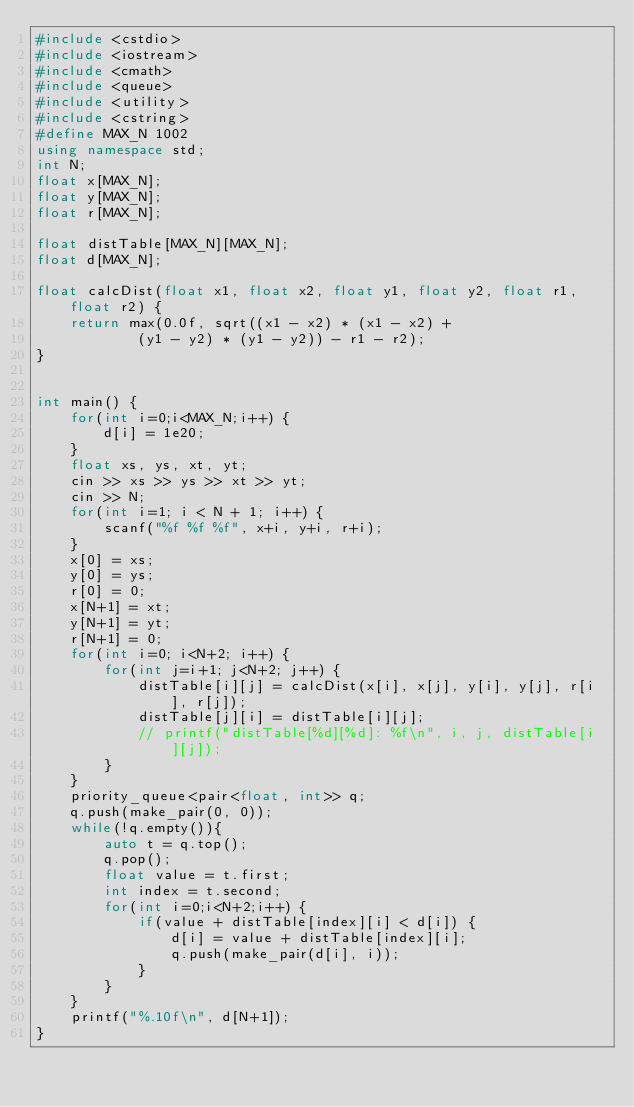<code> <loc_0><loc_0><loc_500><loc_500><_C++_>#include <cstdio>
#include <iostream>
#include <cmath>
#include <queue>
#include <utility>
#include <cstring>
#define MAX_N 1002
using namespace std;
int N;
float x[MAX_N];
float y[MAX_N];
float r[MAX_N];

float distTable[MAX_N][MAX_N];
float d[MAX_N];

float calcDist(float x1, float x2, float y1, float y2, float r1, float r2) {
    return max(0.0f, sqrt((x1 - x2) * (x1 - x2) +
            (y1 - y2) * (y1 - y2)) - r1 - r2);
}


int main() {
    for(int i=0;i<MAX_N;i++) {
        d[i] = 1e20;
    }
    float xs, ys, xt, yt;
    cin >> xs >> ys >> xt >> yt;
    cin >> N;
    for(int i=1; i < N + 1; i++) {
        scanf("%f %f %f", x+i, y+i, r+i);
    }
    x[0] = xs;
    y[0] = ys;
    r[0] = 0;
    x[N+1] = xt;
    y[N+1] = yt;
    r[N+1] = 0;
    for(int i=0; i<N+2; i++) {
        for(int j=i+1; j<N+2; j++) {
            distTable[i][j] = calcDist(x[i], x[j], y[i], y[j], r[i], r[j]);
            distTable[j][i] = distTable[i][j];
            // printf("distTable[%d][%d]: %f\n", i, j, distTable[i][j]);
        }
    }
    priority_queue<pair<float, int>> q;
    q.push(make_pair(0, 0));
    while(!q.empty()){
        auto t = q.top();
        q.pop();
        float value = t.first;
        int index = t.second;
        for(int i=0;i<N+2;i++) {
            if(value + distTable[index][i] < d[i]) {
                d[i] = value + distTable[index][i];
                q.push(make_pair(d[i], i));
            }
        }
    }
    printf("%.10f\n", d[N+1]);
}
</code> 